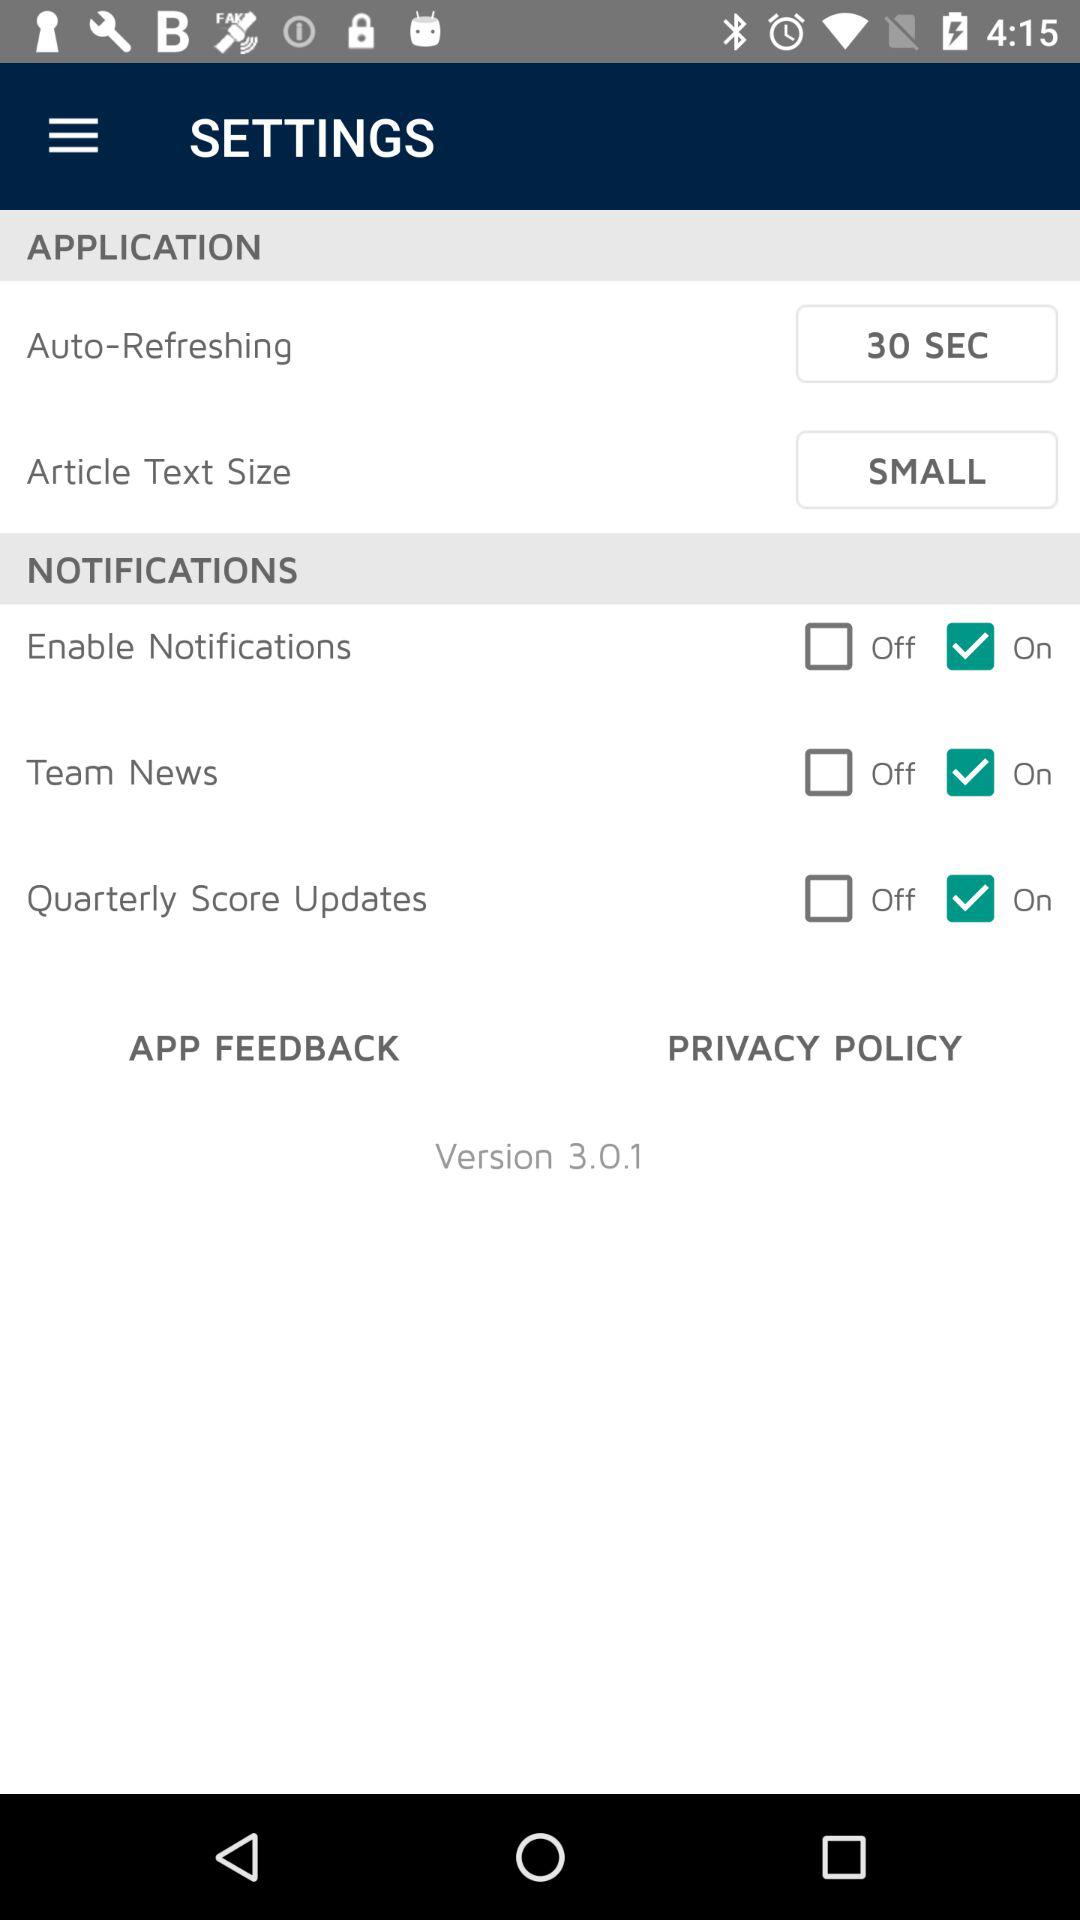Is the "Team News" option in "NOTIFICATIONS" on or off? The "Team News" option in "NOTIFICATIONS" is "On". 